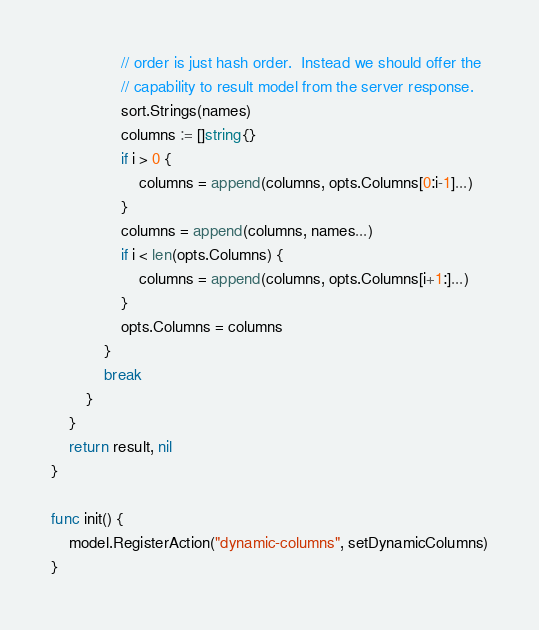<code> <loc_0><loc_0><loc_500><loc_500><_Go_>				// order is just hash order.  Instead we should offer the
				// capability to result model from the server response.
				sort.Strings(names)
				columns := []string{}
				if i > 0 {
					columns = append(columns, opts.Columns[0:i-1]...)
				}
				columns = append(columns, names...)
				if i < len(opts.Columns) {
					columns = append(columns, opts.Columns[i+1:]...)
				}
				opts.Columns = columns
			}
			break
		}
	}
	return result, nil
}

func init() {
	model.RegisterAction("dynamic-columns", setDynamicColumns)
}
</code> 